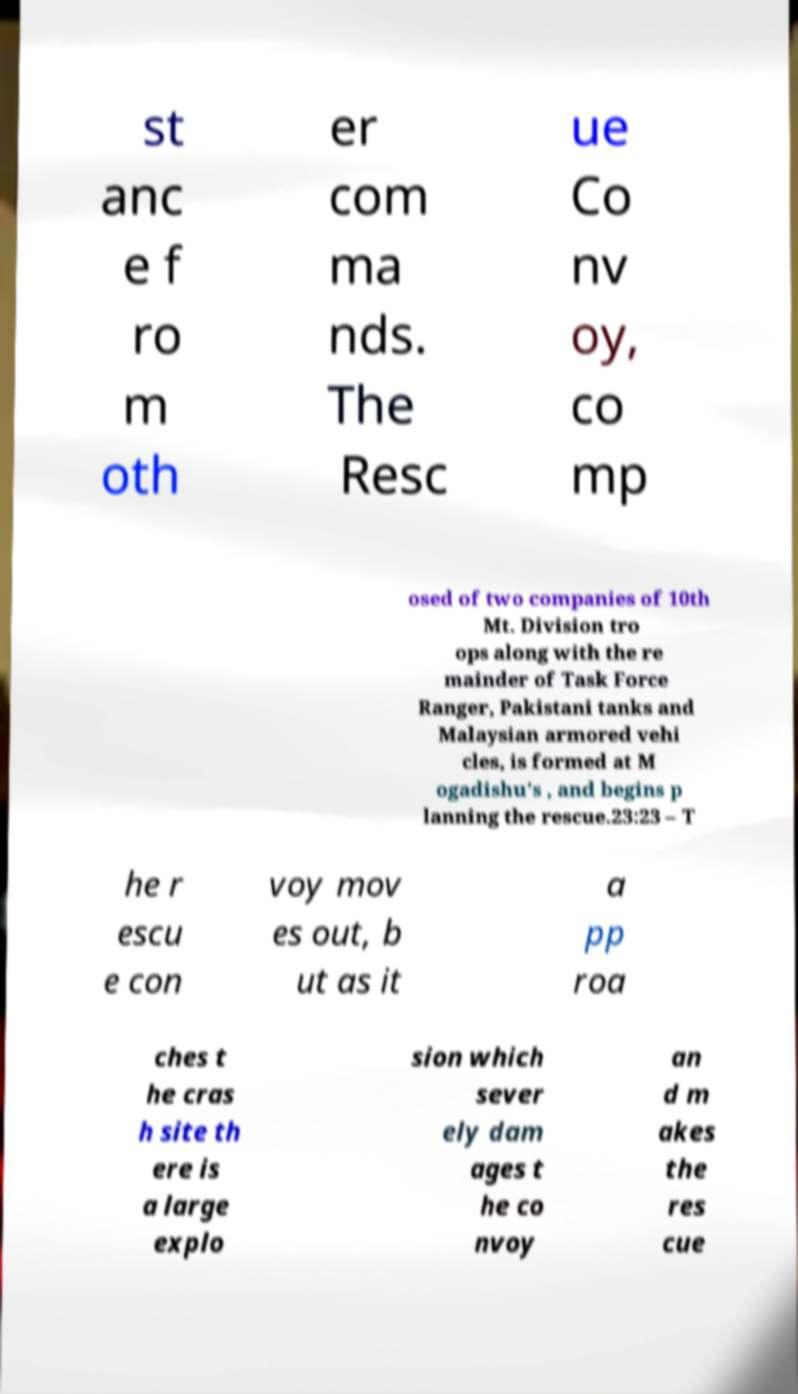Please read and relay the text visible in this image. What does it say? st anc e f ro m oth er com ma nds. The Resc ue Co nv oy, co mp osed of two companies of 10th Mt. Division tro ops along with the re mainder of Task Force Ranger, Pakistani tanks and Malaysian armored vehi cles, is formed at M ogadishu's , and begins p lanning the rescue.23:23 – T he r escu e con voy mov es out, b ut as it a pp roa ches t he cras h site th ere is a large explo sion which sever ely dam ages t he co nvoy an d m akes the res cue 